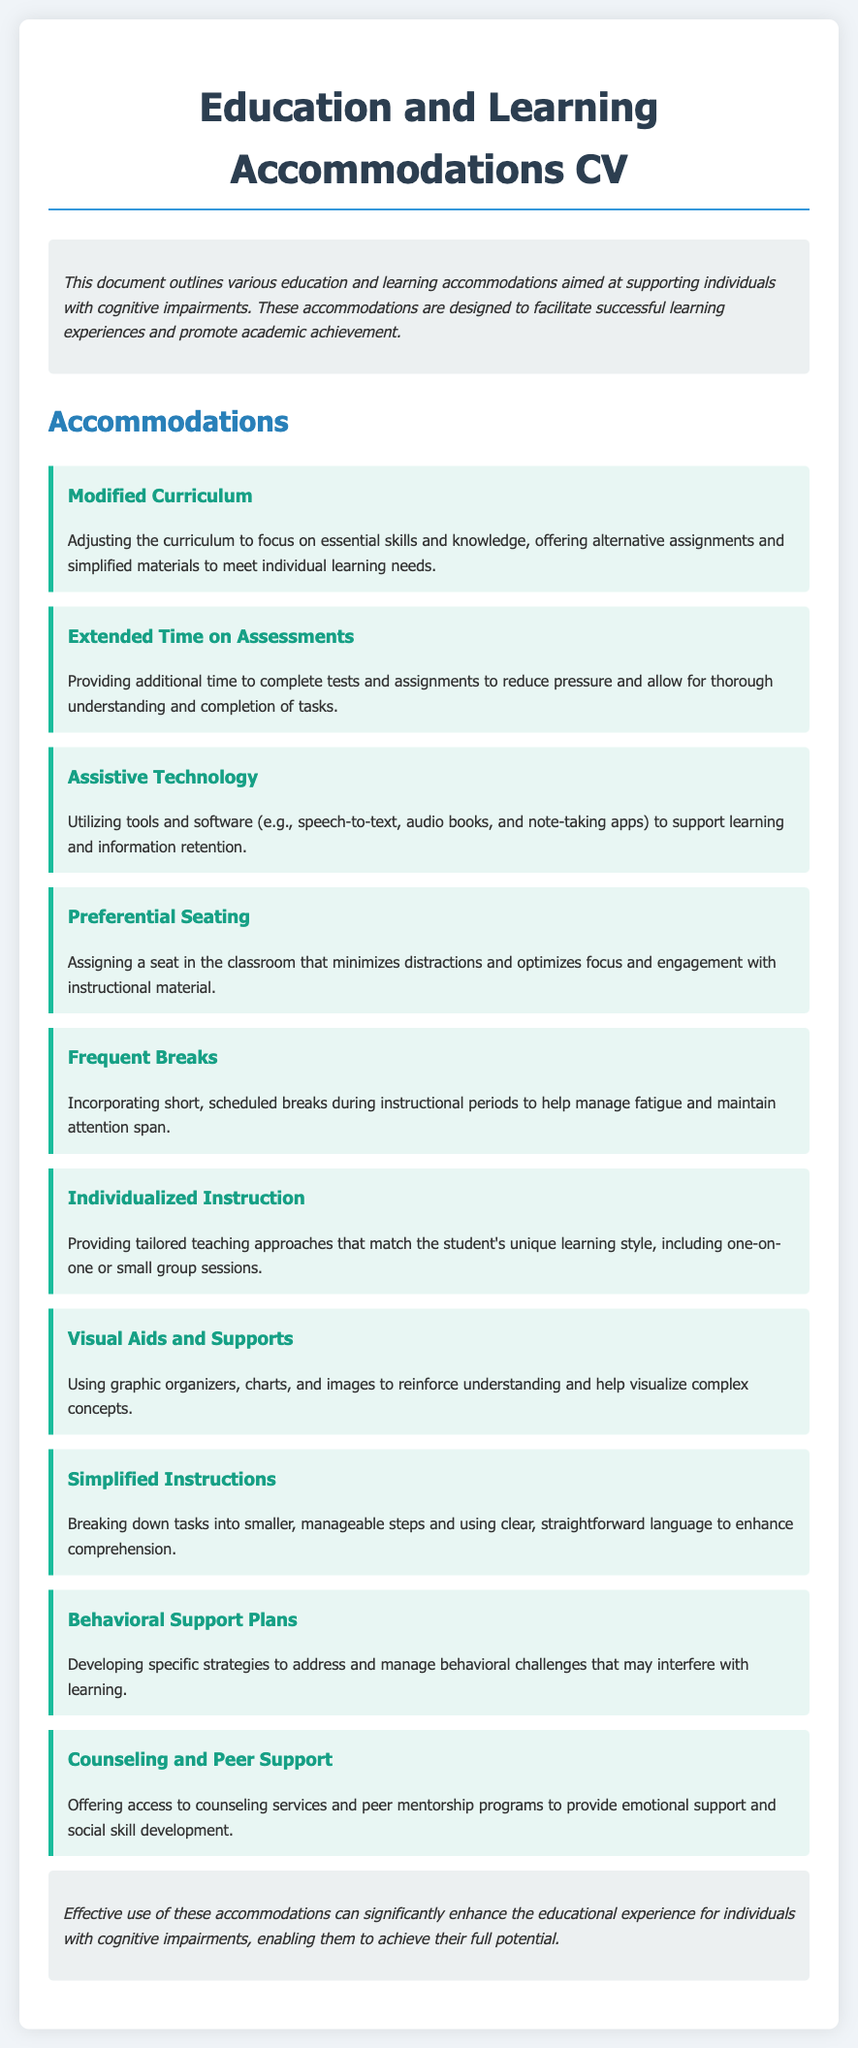What is the purpose of the document? The purpose of the document is to outline various education and learning accommodations aimed at supporting individuals with cognitive impairments.
Answer: Supporting individuals with cognitive impairments What is one type of accommodation mentioned? The document lists various accommodations, one of which is modifying the curriculum.
Answer: Modified Curriculum How many accommodations are listed? The document specifies ten different accommodations.
Answer: Ten What is provided to reduce pressure during assessments? Extended time on assessments is provided to help alleviate pressure.
Answer: Extended time What aids are used to reinforce understanding? The use of visual aids and supports is highlighted to help reinforce understanding.
Answer: Visual aids and supports What is one approach of individualized instruction? One approach includes one-on-one or small group sessions tailored to the student's learning style.
Answer: One-on-one sessions What kind of support is offered for behavioral challenges? Behavioral support plans are developed to address and manage challenges.
Answer: Behavioral support plans What is the benefit of frequent breaks? Incorporating frequent breaks helps manage fatigue and maintain attention span.
Answer: Manage fatigue What type of services does counseling provide? Counseling services offer emotional support and social skill development.
Answer: Emotional support What is a key aspect of the simplified instructions? Simplified instructions involve breaking down tasks into smaller, manageable steps.
Answer: Smaller, manageable steps 